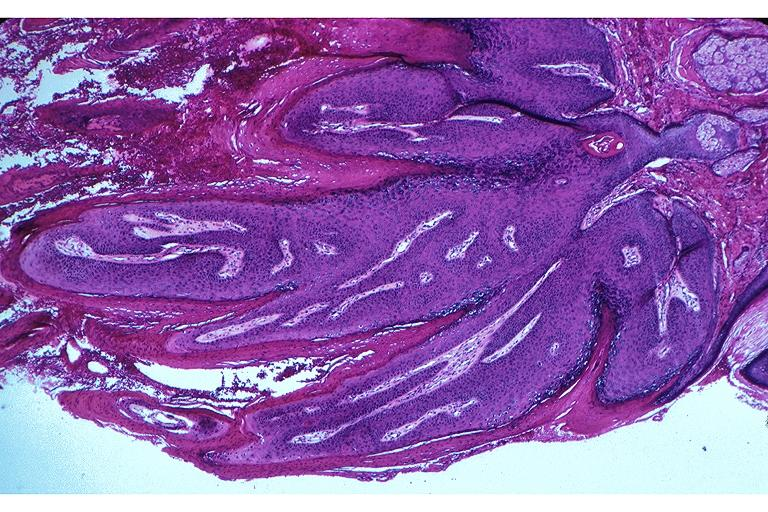what is present?
Answer the question using a single word or phrase. Oral 